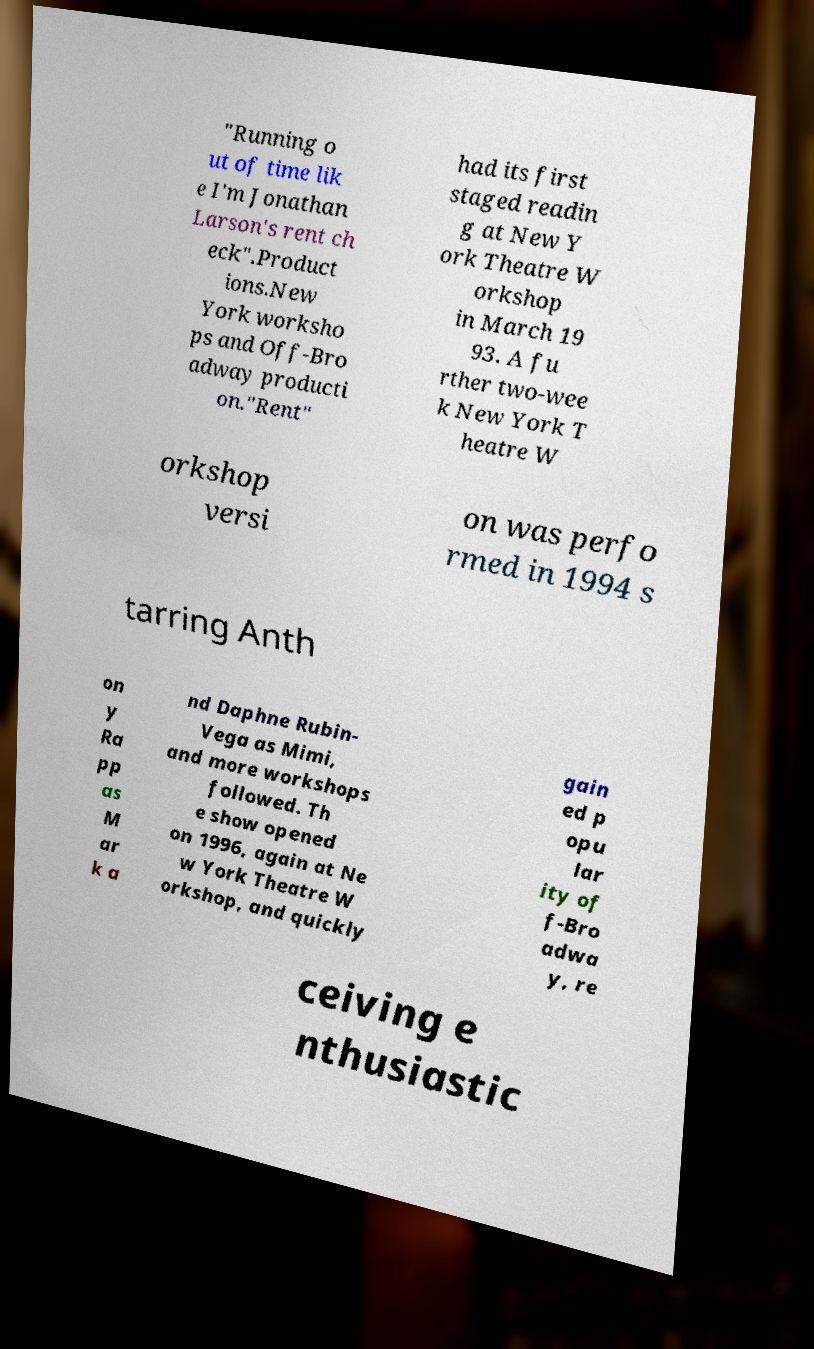Please read and relay the text visible in this image. What does it say? "Running o ut of time lik e I'm Jonathan Larson's rent ch eck".Product ions.New York worksho ps and Off-Bro adway producti on."Rent" had its first staged readin g at New Y ork Theatre W orkshop in March 19 93. A fu rther two-wee k New York T heatre W orkshop versi on was perfo rmed in 1994 s tarring Anth on y Ra pp as M ar k a nd Daphne Rubin- Vega as Mimi, and more workshops followed. Th e show opened on 1996, again at Ne w York Theatre W orkshop, and quickly gain ed p opu lar ity of f-Bro adwa y, re ceiving e nthusiastic 